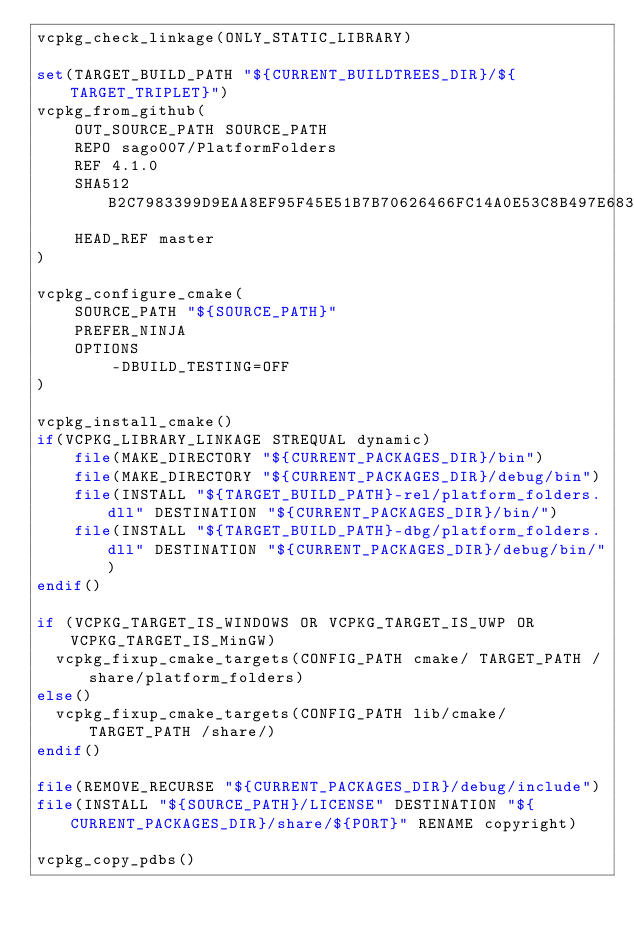Convert code to text. <code><loc_0><loc_0><loc_500><loc_500><_CMake_>vcpkg_check_linkage(ONLY_STATIC_LIBRARY)

set(TARGET_BUILD_PATH "${CURRENT_BUILDTREES_DIR}/${TARGET_TRIPLET}")
vcpkg_from_github(
    OUT_SOURCE_PATH SOURCE_PATH
    REPO sago007/PlatformFolders
    REF 4.1.0
    SHA512 B2C7983399D9EAA8EF95F45E51B7B70626466FC14A0E53C8B497E683D63E40683CC995C75FC9529C7E969BB802CF9C92051B663901326985722AEBF7618C48EB
    HEAD_REF master
)

vcpkg_configure_cmake(
    SOURCE_PATH "${SOURCE_PATH}"
    PREFER_NINJA
    OPTIONS
        -DBUILD_TESTING=OFF
)

vcpkg_install_cmake()
if(VCPKG_LIBRARY_LINKAGE STREQUAL dynamic)
    file(MAKE_DIRECTORY "${CURRENT_PACKAGES_DIR}/bin")
    file(MAKE_DIRECTORY "${CURRENT_PACKAGES_DIR}/debug/bin")
    file(INSTALL "${TARGET_BUILD_PATH}-rel/platform_folders.dll" DESTINATION "${CURRENT_PACKAGES_DIR}/bin/")
    file(INSTALL "${TARGET_BUILD_PATH}-dbg/platform_folders.dll" DESTINATION "${CURRENT_PACKAGES_DIR}/debug/bin/")
endif()

if (VCPKG_TARGET_IS_WINDOWS OR VCPKG_TARGET_IS_UWP OR VCPKG_TARGET_IS_MinGW)
	vcpkg_fixup_cmake_targets(CONFIG_PATH cmake/ TARGET_PATH /share/platform_folders)
else()
	vcpkg_fixup_cmake_targets(CONFIG_PATH lib/cmake/ TARGET_PATH /share/)
endif()

file(REMOVE_RECURSE "${CURRENT_PACKAGES_DIR}/debug/include")
file(INSTALL "${SOURCE_PATH}/LICENSE" DESTINATION "${CURRENT_PACKAGES_DIR}/share/${PORT}" RENAME copyright)

vcpkg_copy_pdbs()
</code> 